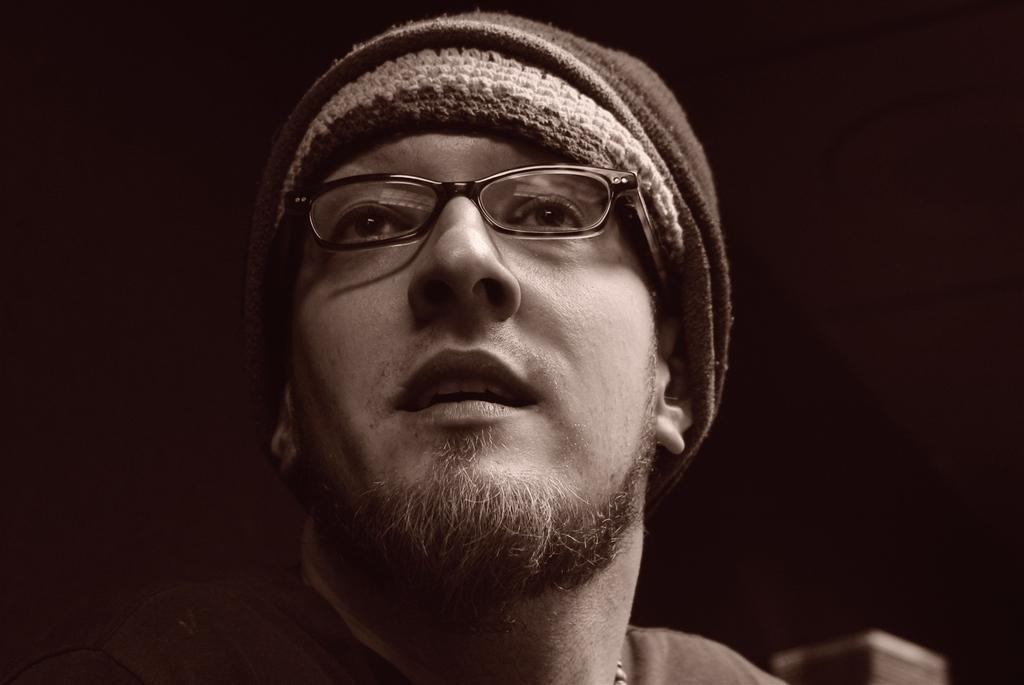What is the color scheme of the image? The image is black and white. Who is present in the image? There is a man in the image. What accessories is the man wearing? The man is wearing spectacles and a cap. What type of fowl can be seen in the image? There is no fowl present in the image; it features a man wearing spectacles and a cap. What is the man trying to control with his hands in the image? There is no indication in the image that the man is trying to control anything with his hands. 